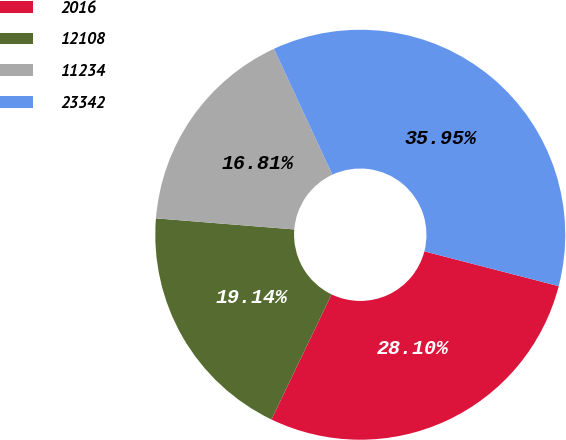Convert chart. <chart><loc_0><loc_0><loc_500><loc_500><pie_chart><fcel>2016<fcel>12108<fcel>11234<fcel>23342<nl><fcel>28.1%<fcel>19.14%<fcel>16.81%<fcel>35.95%<nl></chart> 